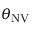Convert formula to latex. <formula><loc_0><loc_0><loc_500><loc_500>\theta _ { N V }</formula> 